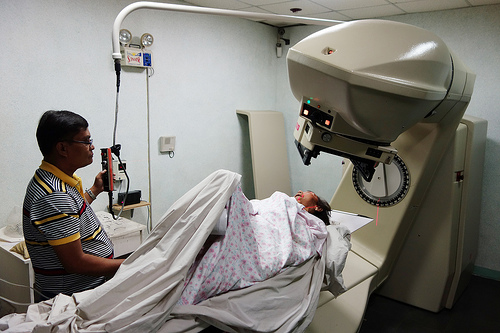<image>
Is the woman under the scanner? Yes. The woman is positioned underneath the scanner, with the scanner above it in the vertical space. 